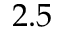<formula> <loc_0><loc_0><loc_500><loc_500>2 . 5</formula> 